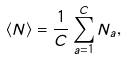<formula> <loc_0><loc_0><loc_500><loc_500>\langle N \rangle = \frac { 1 } { C } \sum _ { a = 1 } ^ { C } N _ { a } ,</formula> 